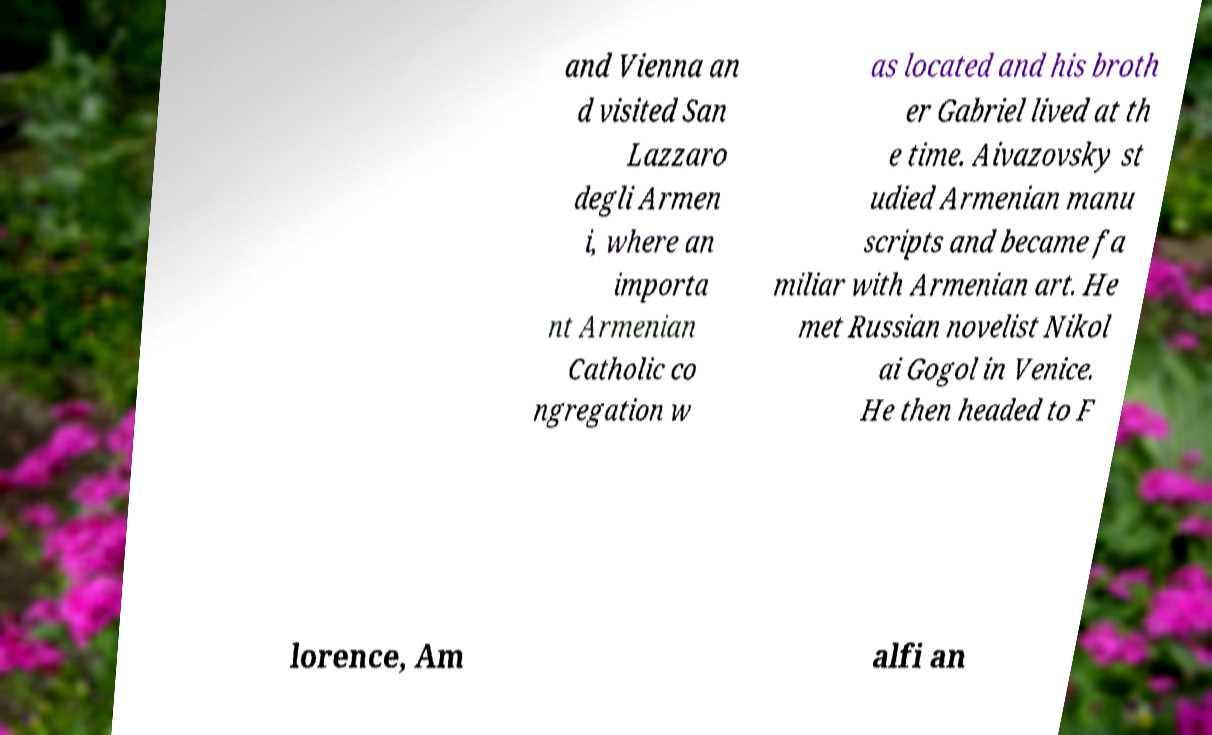Please read and relay the text visible in this image. What does it say? and Vienna an d visited San Lazzaro degli Armen i, where an importa nt Armenian Catholic co ngregation w as located and his broth er Gabriel lived at th e time. Aivazovsky st udied Armenian manu scripts and became fa miliar with Armenian art. He met Russian novelist Nikol ai Gogol in Venice. He then headed to F lorence, Am alfi an 